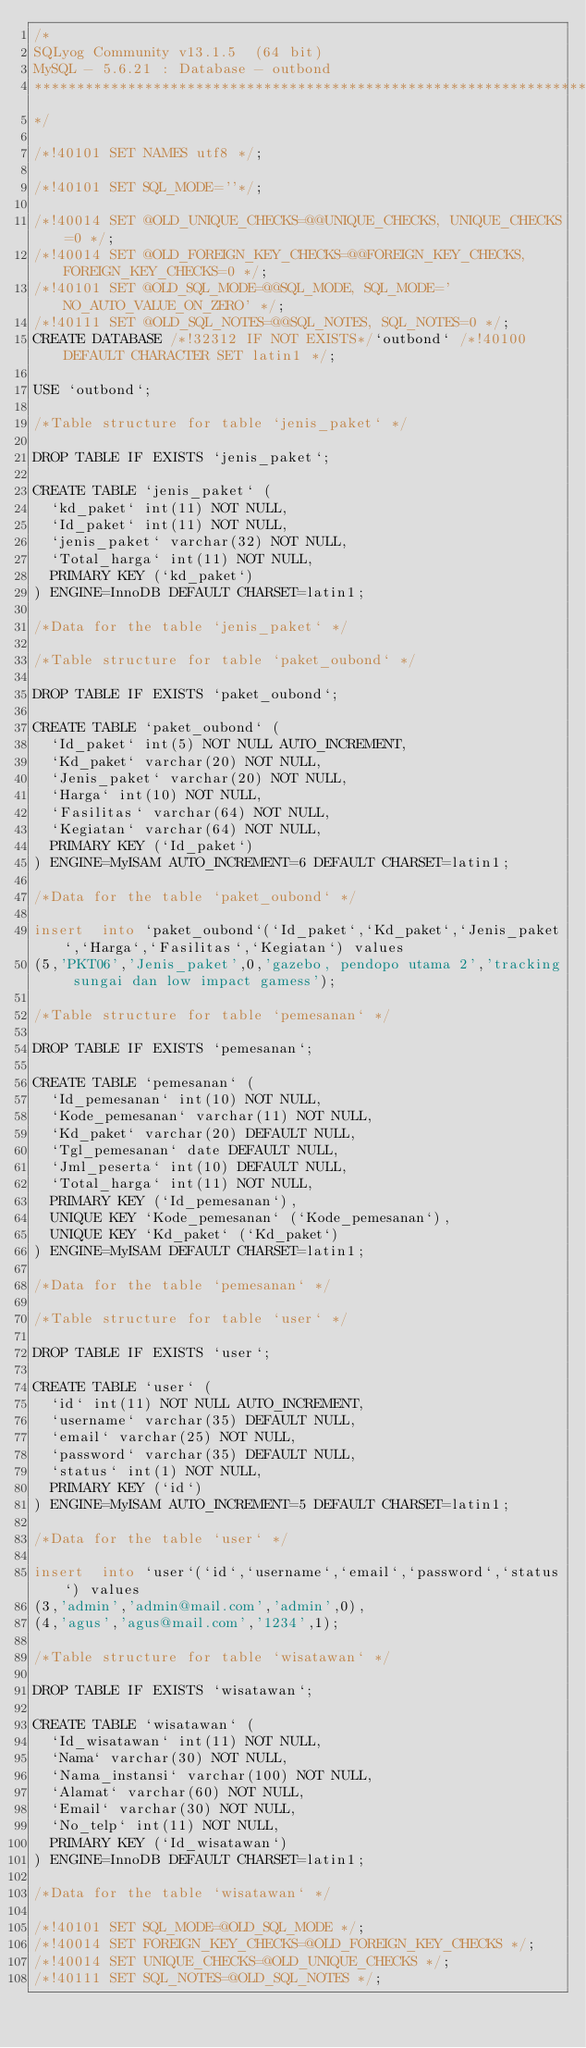Convert code to text. <code><loc_0><loc_0><loc_500><loc_500><_SQL_>/*
SQLyog Community v13.1.5  (64 bit)
MySQL - 5.6.21 : Database - outbond
*********************************************************************
*/

/*!40101 SET NAMES utf8 */;

/*!40101 SET SQL_MODE=''*/;

/*!40014 SET @OLD_UNIQUE_CHECKS=@@UNIQUE_CHECKS, UNIQUE_CHECKS=0 */;
/*!40014 SET @OLD_FOREIGN_KEY_CHECKS=@@FOREIGN_KEY_CHECKS, FOREIGN_KEY_CHECKS=0 */;
/*!40101 SET @OLD_SQL_MODE=@@SQL_MODE, SQL_MODE='NO_AUTO_VALUE_ON_ZERO' */;
/*!40111 SET @OLD_SQL_NOTES=@@SQL_NOTES, SQL_NOTES=0 */;
CREATE DATABASE /*!32312 IF NOT EXISTS*/`outbond` /*!40100 DEFAULT CHARACTER SET latin1 */;

USE `outbond`;

/*Table structure for table `jenis_paket` */

DROP TABLE IF EXISTS `jenis_paket`;

CREATE TABLE `jenis_paket` (
  `kd_paket` int(11) NOT NULL,
  `Id_paket` int(11) NOT NULL,
  `jenis_paket` varchar(32) NOT NULL,
  `Total_harga` int(11) NOT NULL,
  PRIMARY KEY (`kd_paket`)
) ENGINE=InnoDB DEFAULT CHARSET=latin1;

/*Data for the table `jenis_paket` */

/*Table structure for table `paket_oubond` */

DROP TABLE IF EXISTS `paket_oubond`;

CREATE TABLE `paket_oubond` (
  `Id_paket` int(5) NOT NULL AUTO_INCREMENT,
  `Kd_paket` varchar(20) NOT NULL,
  `Jenis_paket` varchar(20) NOT NULL,
  `Harga` int(10) NOT NULL,
  `Fasilitas` varchar(64) NOT NULL,
  `Kegiatan` varchar(64) NOT NULL,
  PRIMARY KEY (`Id_paket`)
) ENGINE=MyISAM AUTO_INCREMENT=6 DEFAULT CHARSET=latin1;

/*Data for the table `paket_oubond` */

insert  into `paket_oubond`(`Id_paket`,`Kd_paket`,`Jenis_paket`,`Harga`,`Fasilitas`,`Kegiatan`) values 
(5,'PKT06','Jenis_paket',0,'gazebo, pendopo utama 2','tracking sungai dan low impact gamess');

/*Table structure for table `pemesanan` */

DROP TABLE IF EXISTS `pemesanan`;

CREATE TABLE `pemesanan` (
  `Id_pemesanan` int(10) NOT NULL,
  `Kode_pemesanan` varchar(11) NOT NULL,
  `Kd_paket` varchar(20) DEFAULT NULL,
  `Tgl_pemesanan` date DEFAULT NULL,
  `Jml_peserta` int(10) DEFAULT NULL,
  `Total_harga` int(11) NOT NULL,
  PRIMARY KEY (`Id_pemesanan`),
  UNIQUE KEY `Kode_pemesanan` (`Kode_pemesanan`),
  UNIQUE KEY `Kd_paket` (`Kd_paket`)
) ENGINE=MyISAM DEFAULT CHARSET=latin1;

/*Data for the table `pemesanan` */

/*Table structure for table `user` */

DROP TABLE IF EXISTS `user`;

CREATE TABLE `user` (
  `id` int(11) NOT NULL AUTO_INCREMENT,
  `username` varchar(35) DEFAULT NULL,
  `email` varchar(25) NOT NULL,
  `password` varchar(35) DEFAULT NULL,
  `status` int(1) NOT NULL,
  PRIMARY KEY (`id`)
) ENGINE=MyISAM AUTO_INCREMENT=5 DEFAULT CHARSET=latin1;

/*Data for the table `user` */

insert  into `user`(`id`,`username`,`email`,`password`,`status`) values 
(3,'admin','admin@mail.com','admin',0),
(4,'agus','agus@mail.com','1234',1);

/*Table structure for table `wisatawan` */

DROP TABLE IF EXISTS `wisatawan`;

CREATE TABLE `wisatawan` (
  `Id_wisatawan` int(11) NOT NULL,
  `Nama` varchar(30) NOT NULL,
  `Nama_instansi` varchar(100) NOT NULL,
  `Alamat` varchar(60) NOT NULL,
  `Email` varchar(30) NOT NULL,
  `No_telp` int(11) NOT NULL,
  PRIMARY KEY (`Id_wisatawan`)
) ENGINE=InnoDB DEFAULT CHARSET=latin1;

/*Data for the table `wisatawan` */

/*!40101 SET SQL_MODE=@OLD_SQL_MODE */;
/*!40014 SET FOREIGN_KEY_CHECKS=@OLD_FOREIGN_KEY_CHECKS */;
/*!40014 SET UNIQUE_CHECKS=@OLD_UNIQUE_CHECKS */;
/*!40111 SET SQL_NOTES=@OLD_SQL_NOTES */;
</code> 